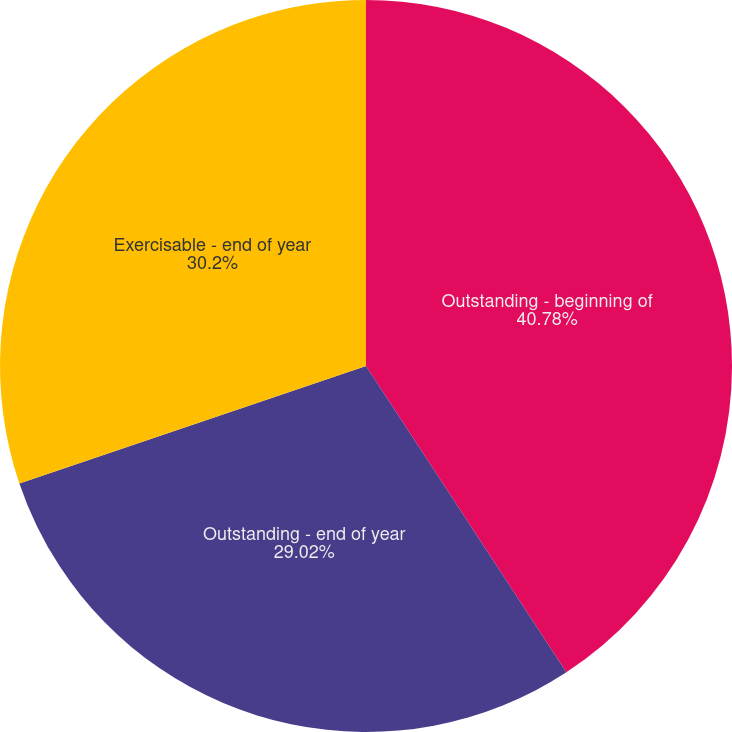Convert chart. <chart><loc_0><loc_0><loc_500><loc_500><pie_chart><fcel>Outstanding - beginning of<fcel>Outstanding - end of year<fcel>Exercisable - end of year<nl><fcel>40.78%<fcel>29.02%<fcel>30.2%<nl></chart> 